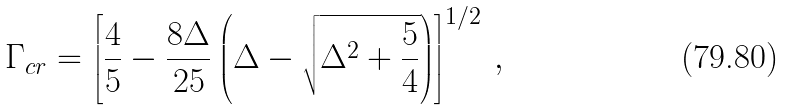Convert formula to latex. <formula><loc_0><loc_0><loc_500><loc_500>\Gamma _ { c r } = \left [ \frac { 4 } { 5 } - \frac { 8 \Delta } { 2 5 } \left ( \Delta - \sqrt { \Delta ^ { 2 } + \frac { 5 } { 4 } } \right ) \right ] ^ { 1 / 2 } \, ,</formula> 